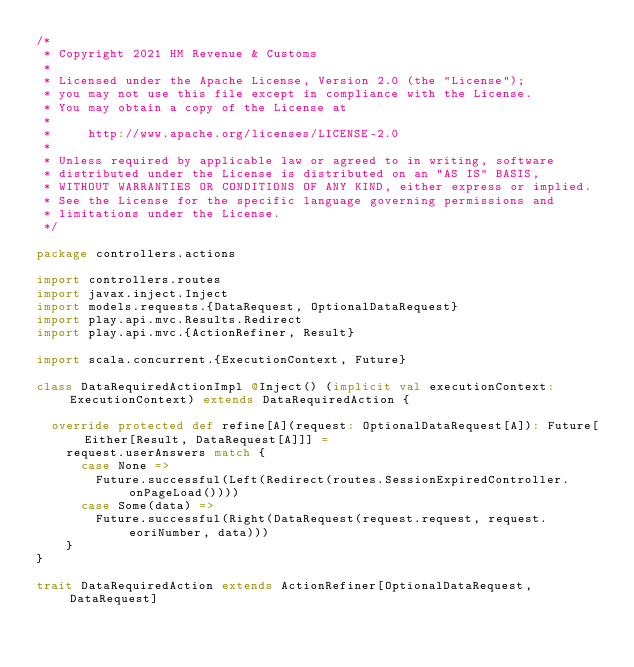<code> <loc_0><loc_0><loc_500><loc_500><_Scala_>/*
 * Copyright 2021 HM Revenue & Customs
 *
 * Licensed under the Apache License, Version 2.0 (the "License");
 * you may not use this file except in compliance with the License.
 * You may obtain a copy of the License at
 *
 *     http://www.apache.org/licenses/LICENSE-2.0
 *
 * Unless required by applicable law or agreed to in writing, software
 * distributed under the License is distributed on an "AS IS" BASIS,
 * WITHOUT WARRANTIES OR CONDITIONS OF ANY KIND, either express or implied.
 * See the License for the specific language governing permissions and
 * limitations under the License.
 */

package controllers.actions

import controllers.routes
import javax.inject.Inject
import models.requests.{DataRequest, OptionalDataRequest}
import play.api.mvc.Results.Redirect
import play.api.mvc.{ActionRefiner, Result}

import scala.concurrent.{ExecutionContext, Future}

class DataRequiredActionImpl @Inject() (implicit val executionContext: ExecutionContext) extends DataRequiredAction {

  override protected def refine[A](request: OptionalDataRequest[A]): Future[Either[Result, DataRequest[A]]] =
    request.userAnswers match {
      case None =>
        Future.successful(Left(Redirect(routes.SessionExpiredController.onPageLoad())))
      case Some(data) =>
        Future.successful(Right(DataRequest(request.request, request.eoriNumber, data)))
    }
}

trait DataRequiredAction extends ActionRefiner[OptionalDataRequest, DataRequest]
</code> 